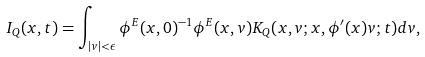Convert formula to latex. <formula><loc_0><loc_0><loc_500><loc_500>I _ { Q } ( x , t ) = \int _ { | v | < \epsilon } \phi ^ { E } ( x , 0 ) ^ { - 1 } \phi ^ { E } ( x , v ) K _ { Q } ( x , v ; x , \phi ^ { \prime } ( x ) v ; t ) d v ,</formula> 